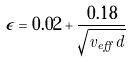Convert formula to latex. <formula><loc_0><loc_0><loc_500><loc_500>\epsilon = 0 . 0 2 + \frac { 0 . 1 8 } { \sqrt { v _ { e f f } d } }</formula> 